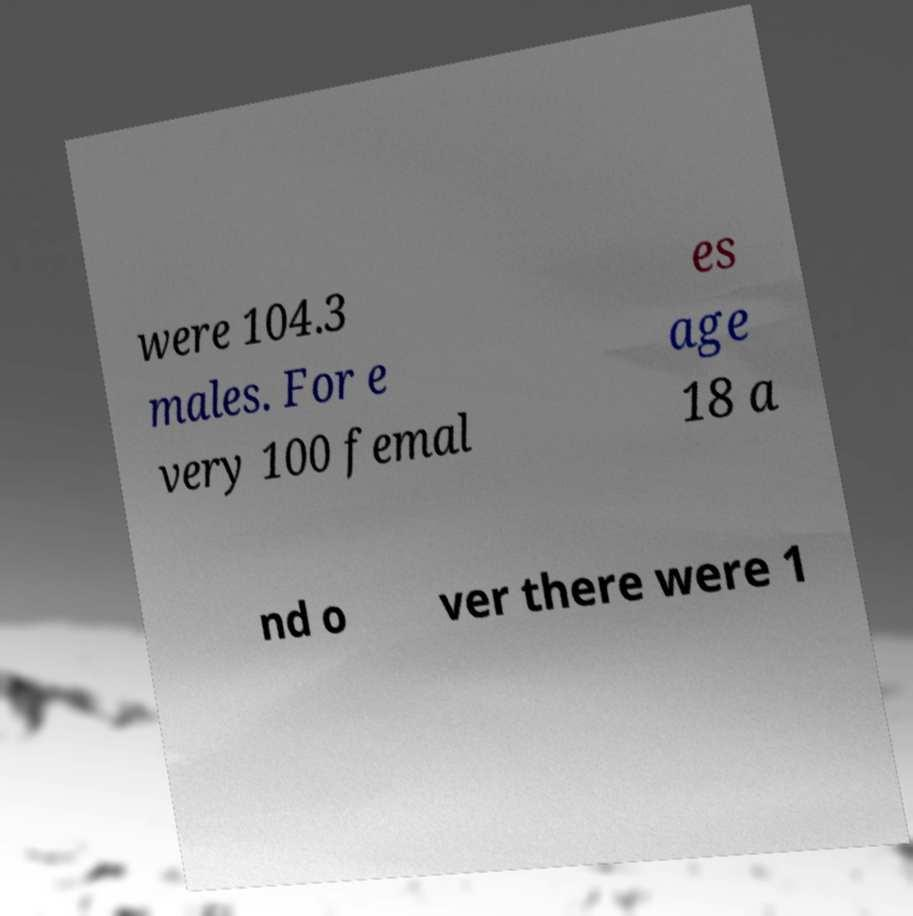Could you extract and type out the text from this image? were 104.3 males. For e very 100 femal es age 18 a nd o ver there were 1 